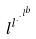<formula> <loc_0><loc_0><loc_500><loc_500>l ^ { l ^ { \cdot ^ { \cdot ^ { l ^ { b } } } } }</formula> 